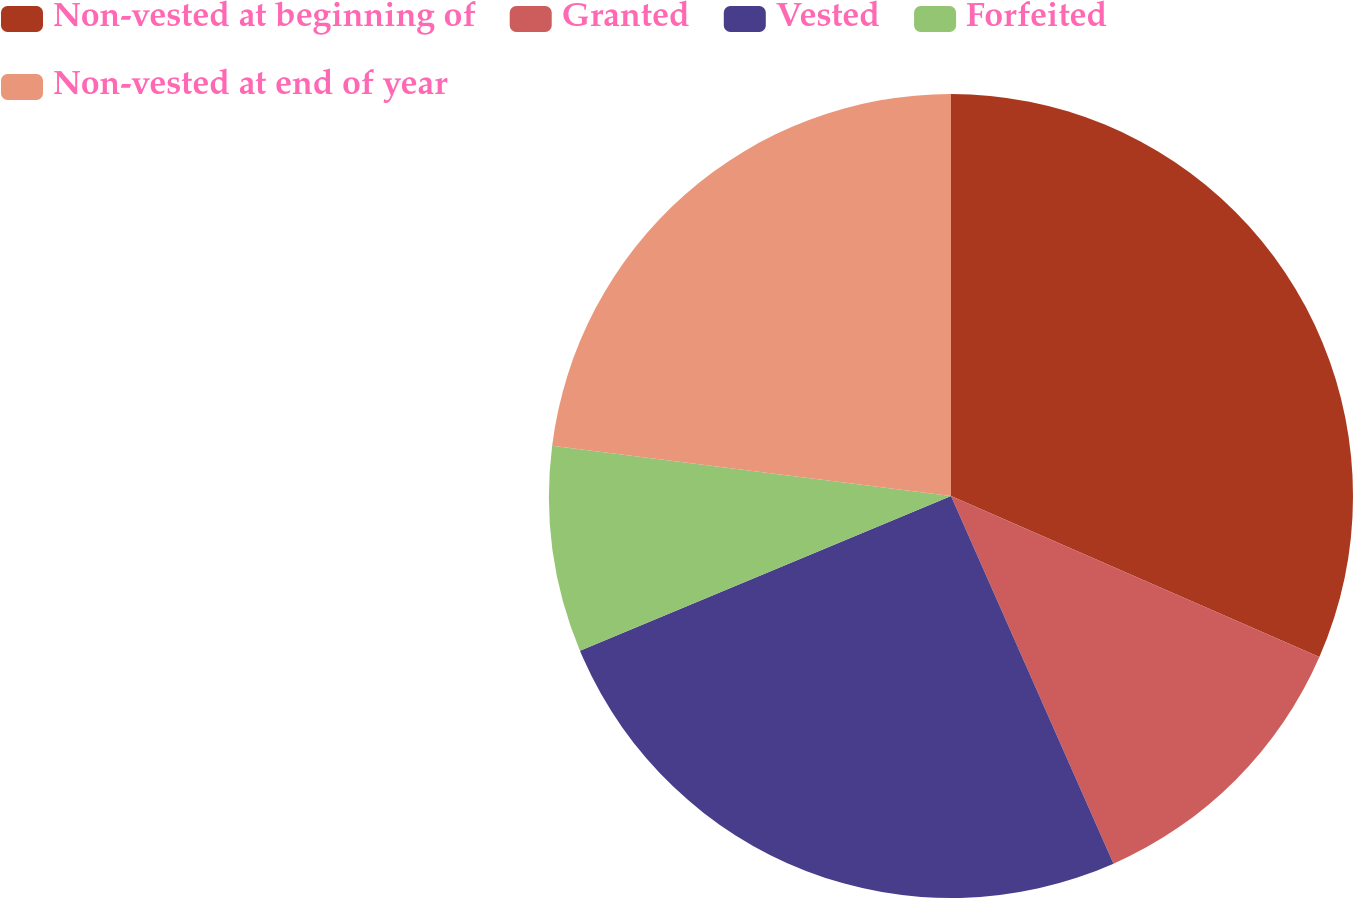Convert chart to OTSL. <chart><loc_0><loc_0><loc_500><loc_500><pie_chart><fcel>Non-vested at beginning of<fcel>Granted<fcel>Vested<fcel>Forfeited<fcel>Non-vested at end of year<nl><fcel>31.56%<fcel>11.82%<fcel>25.34%<fcel>8.28%<fcel>23.01%<nl></chart> 